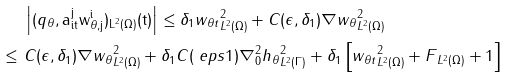<formula> <loc_0><loc_0><loc_500><loc_500>& \ \left | ( q _ { \theta } , \tt a _ { i t } ^ { j } w _ { \theta , j } ^ { i } ) _ { L ^ { 2 } ( \Omega ) } ( t ) \right | \leq \delta _ { 1 } \| w _ { \theta t } \| ^ { 2 } _ { L ^ { 2 } ( \Omega ) } + C ( \epsilon , \delta _ { 1 } ) \| \nabla w _ { \theta } \| ^ { 2 } _ { L ^ { 2 } ( \Omega ) } \\ \leq & \ C ( \epsilon , \delta _ { 1 } ) \| \nabla w _ { \theta } \| ^ { 2 } _ { L ^ { 2 } ( \Omega ) } + \delta _ { 1 } C ( \ e p s 1 ) \| \nabla _ { 0 } ^ { 2 } h _ { \theta } \| ^ { 2 } _ { L ^ { 2 } ( \Gamma ) } + \delta _ { 1 } \left [ \| w _ { \theta t } \| ^ { 2 } _ { L ^ { 2 } ( \Omega ) } + \| F \| _ { L ^ { 2 } ( \Omega ) } + 1 \right ]</formula> 